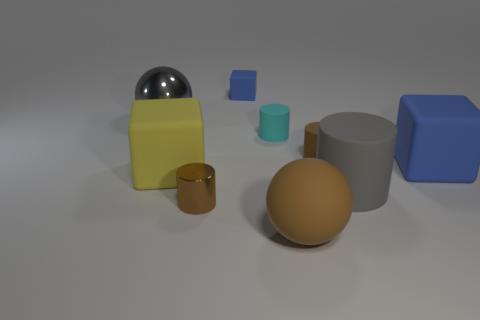Subtract all shiny cylinders. How many cylinders are left? 3 Subtract all yellow cubes. How many cubes are left? 2 Subtract 1 gray balls. How many objects are left? 8 Subtract all balls. How many objects are left? 7 Subtract 2 blocks. How many blocks are left? 1 Subtract all brown blocks. Subtract all red cylinders. How many blocks are left? 3 Subtract all brown cubes. How many gray spheres are left? 1 Subtract all big purple metal spheres. Subtract all blue rubber blocks. How many objects are left? 7 Add 3 tiny rubber cubes. How many tiny rubber cubes are left? 4 Add 6 matte cylinders. How many matte cylinders exist? 9 